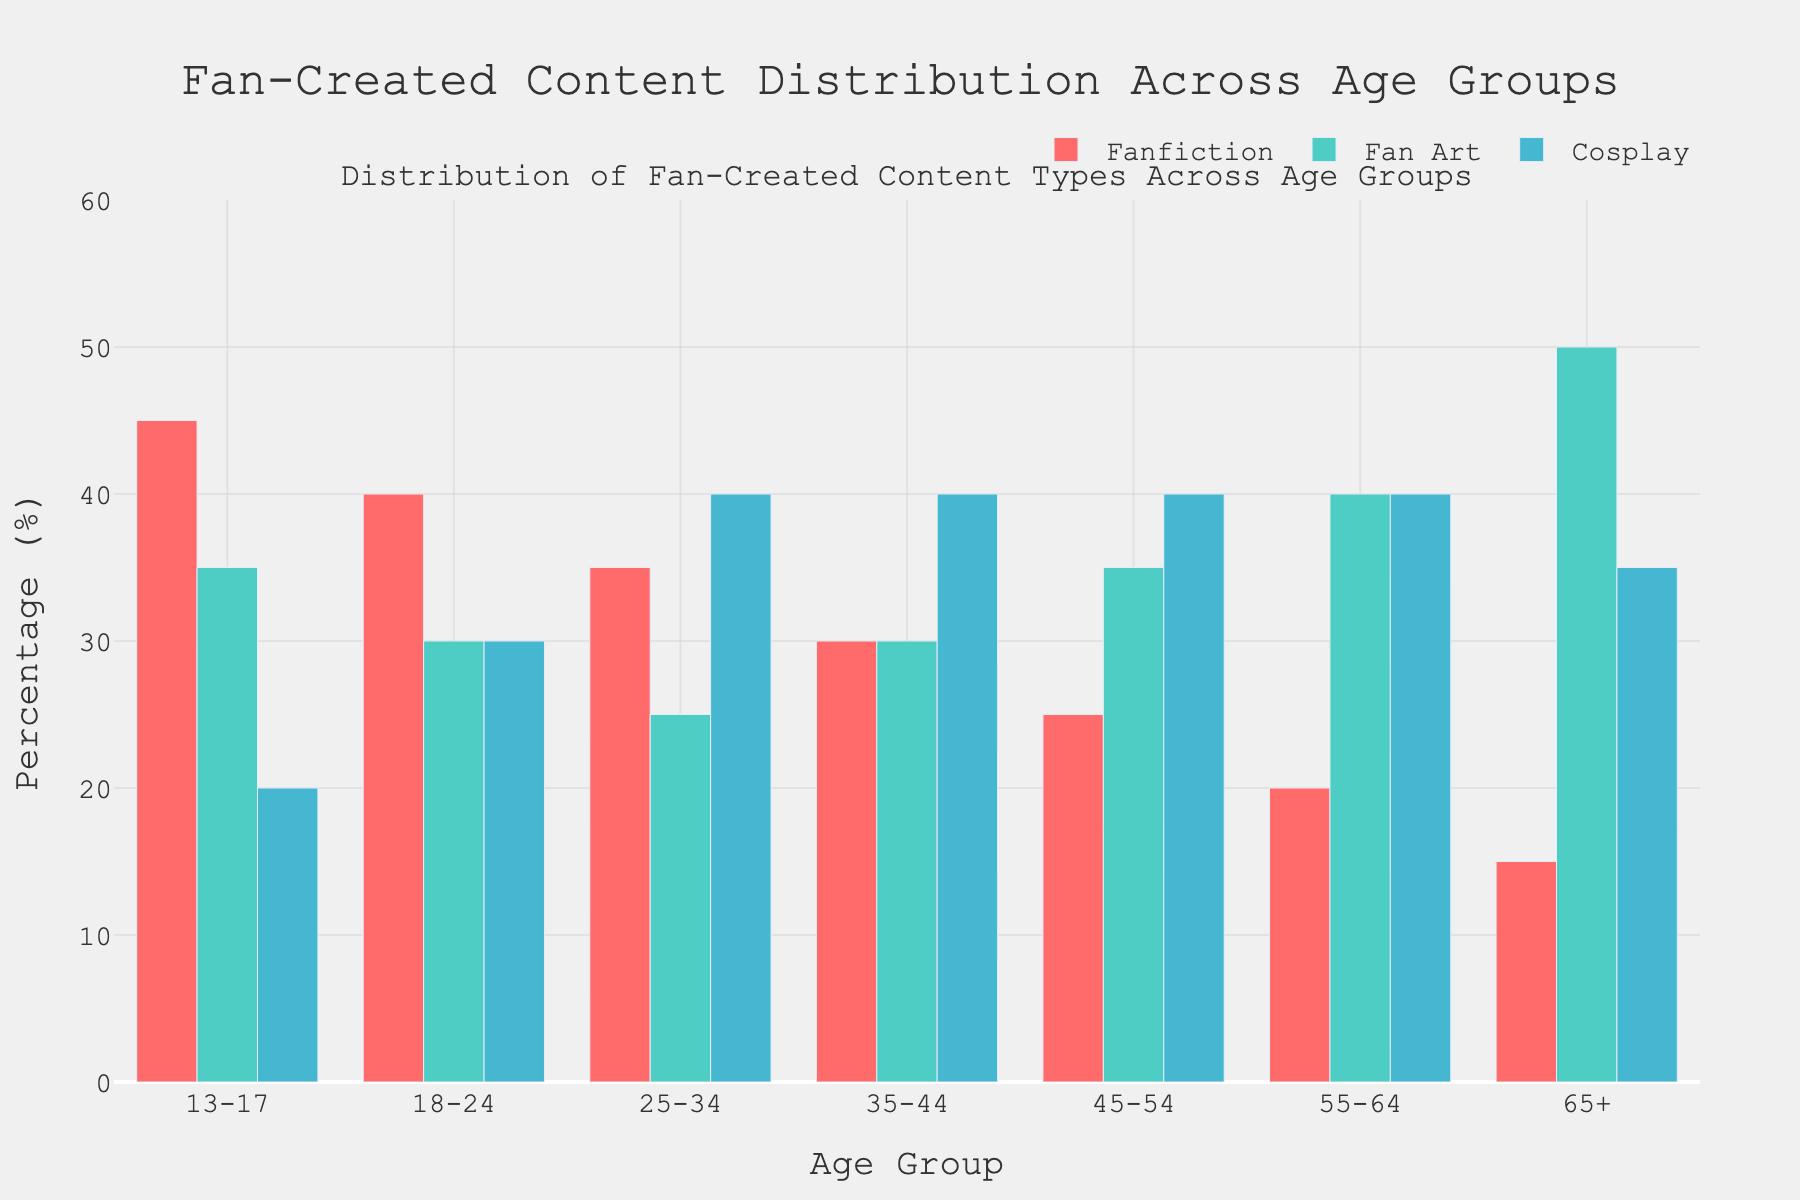What is the age group with the highest percentage of fanfiction creation? By looking at the height of the red bars (representing fanfiction) across the different age groups, the tallest red bar is within the "13-17" age group.
Answer: 13-17 Which content type is most popular among the 55-64 age group? Compare the heights of the three bars for the age group "55-64." The highest bar, which is blue, indicates that cosplay is the most popular.
Answer: Cosplay Are there any age groups where fan art is more popular than fanfiction? By comparing the green and red bars for each age group, fan art is more popular than fanfiction in the "55-64" and "65+" age groups.
Answer: Yes Which age group shows an equal percentage for fanfiction and fan art? Compare the heights of the corresponding red and green bars. In the "35-44" age group, both bars have the same height (30%).
Answer: 35-44 What is the second most popular content type for the 18-24 age group? For the age group "18-24," sort the bars (red, green, blue) by height. The second tallest bar is green, which represents fan art.
Answer: Fan Art What is the percentage difference in fanfiction creation between the 13-17 and 65+ age groups? Subtract the percentage of the 65+ age group from the 13-17 age group (45% - 15%).
Answer: 30% Does the 25-34 age group have a higher percentage of cosplay than fanfiction and fan art combined? Sum the percentages of fanfiction and fan art for the 25-34 age group (35% + 25% = 60%). Compare this sum to the percentage for cosplay (40%). Since 60% > 40%, the combined percentage is higher.
Answer: No Which age group has the highest percentage for fan art creation? By examining the height of the green bars, the tallest green bar is in the "65+" age group.
Answer: 65+ Is fanfiction ever the most popular content type in any age group? By observing the tallest bar among the red, green, and blue bars for each age group, the only age group where fanfiction is the tallest bar is the "13-17" age group.
Answer: Yes How many age groups have at least 40% in cosplay creation? Look at the blue bars and count those which are at least 40%. The age groups "25-34," "35-44," "45-54," and "55-64" meet this criterion.
Answer: 4 